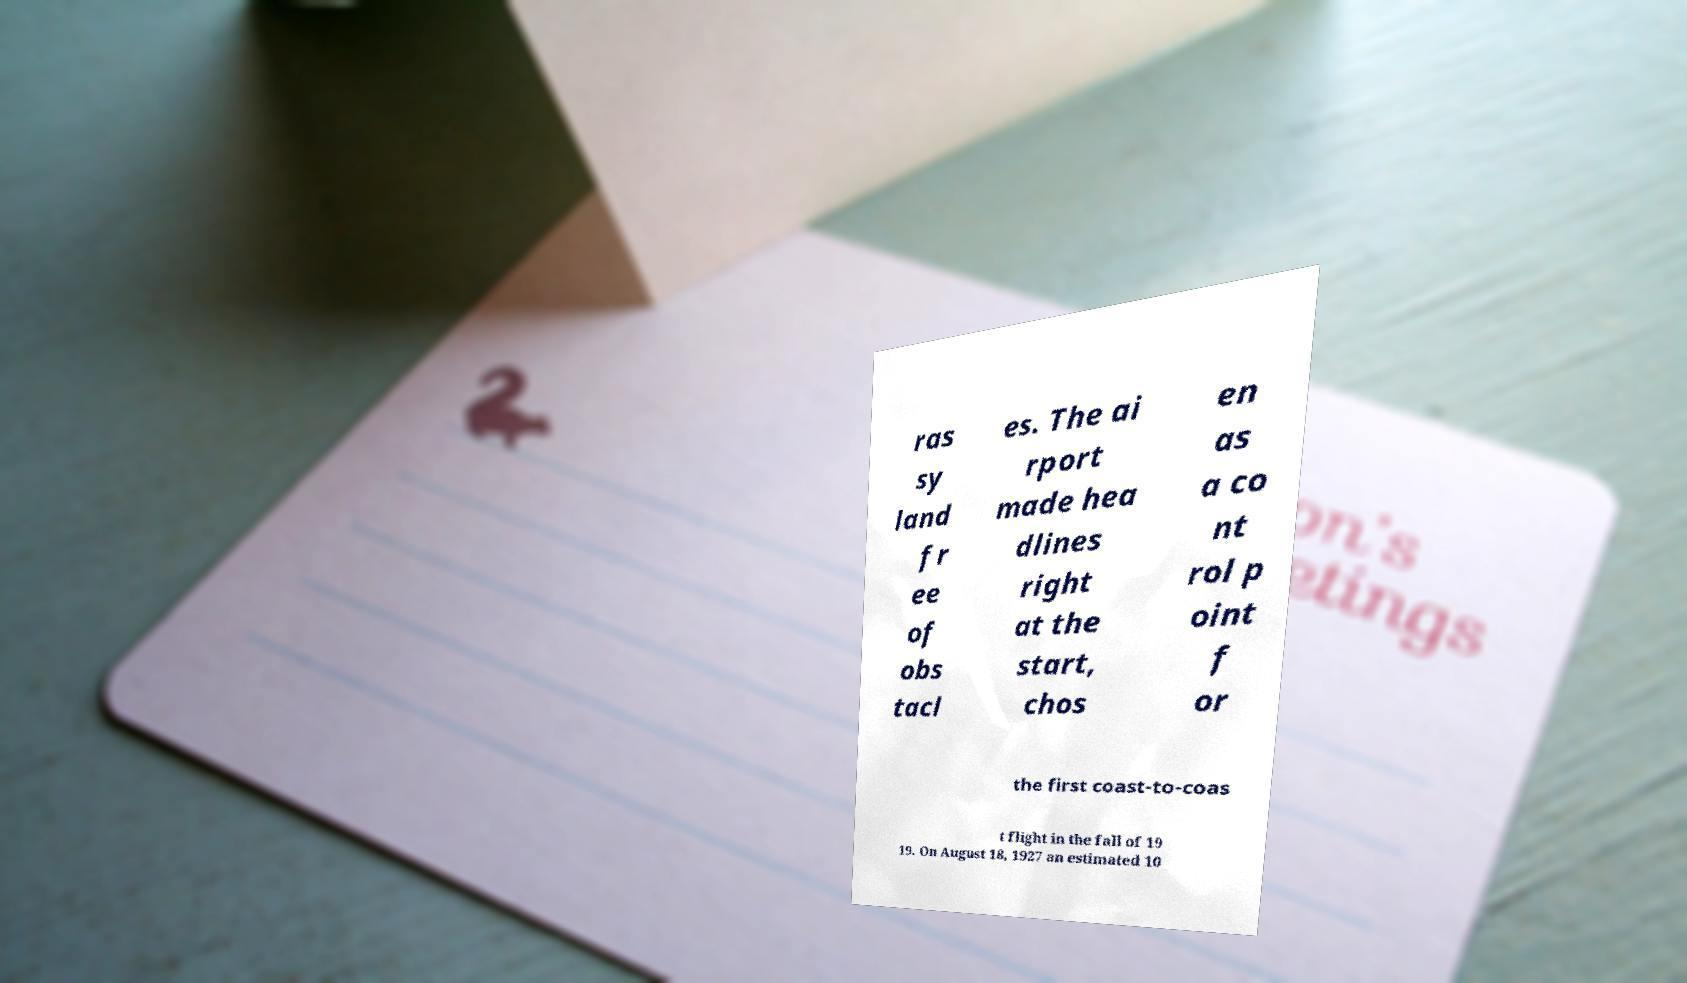Please identify and transcribe the text found in this image. ras sy land fr ee of obs tacl es. The ai rport made hea dlines right at the start, chos en as a co nt rol p oint f or the first coast-to-coas t flight in the fall of 19 19. On August 18, 1927 an estimated 10 